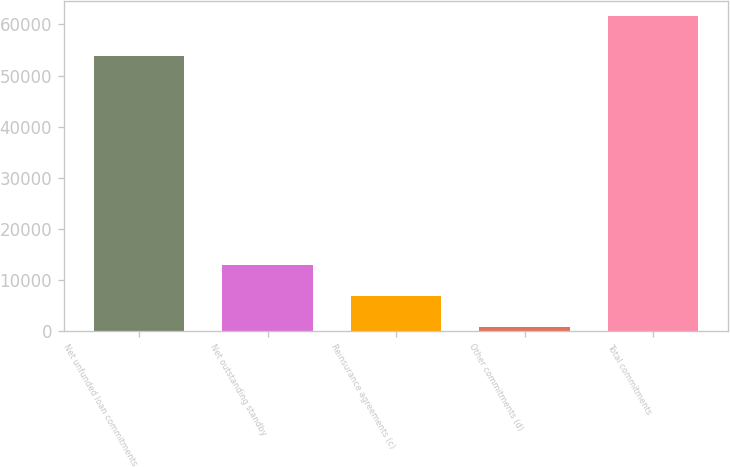<chart> <loc_0><loc_0><loc_500><loc_500><bar_chart><fcel>Net unfunded loan commitments<fcel>Net outstanding standby<fcel>Reinsurance agreements (c)<fcel>Other commitments (d)<fcel>Total commitments<nl><fcel>53849<fcel>12871.6<fcel>6782.3<fcel>693<fcel>61586<nl></chart> 